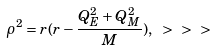Convert formula to latex. <formula><loc_0><loc_0><loc_500><loc_500>\rho ^ { 2 } = r ( r - \frac { Q _ { E } ^ { 2 } + Q _ { M } ^ { 2 } } { M } ) , \ > \ > \ ></formula> 